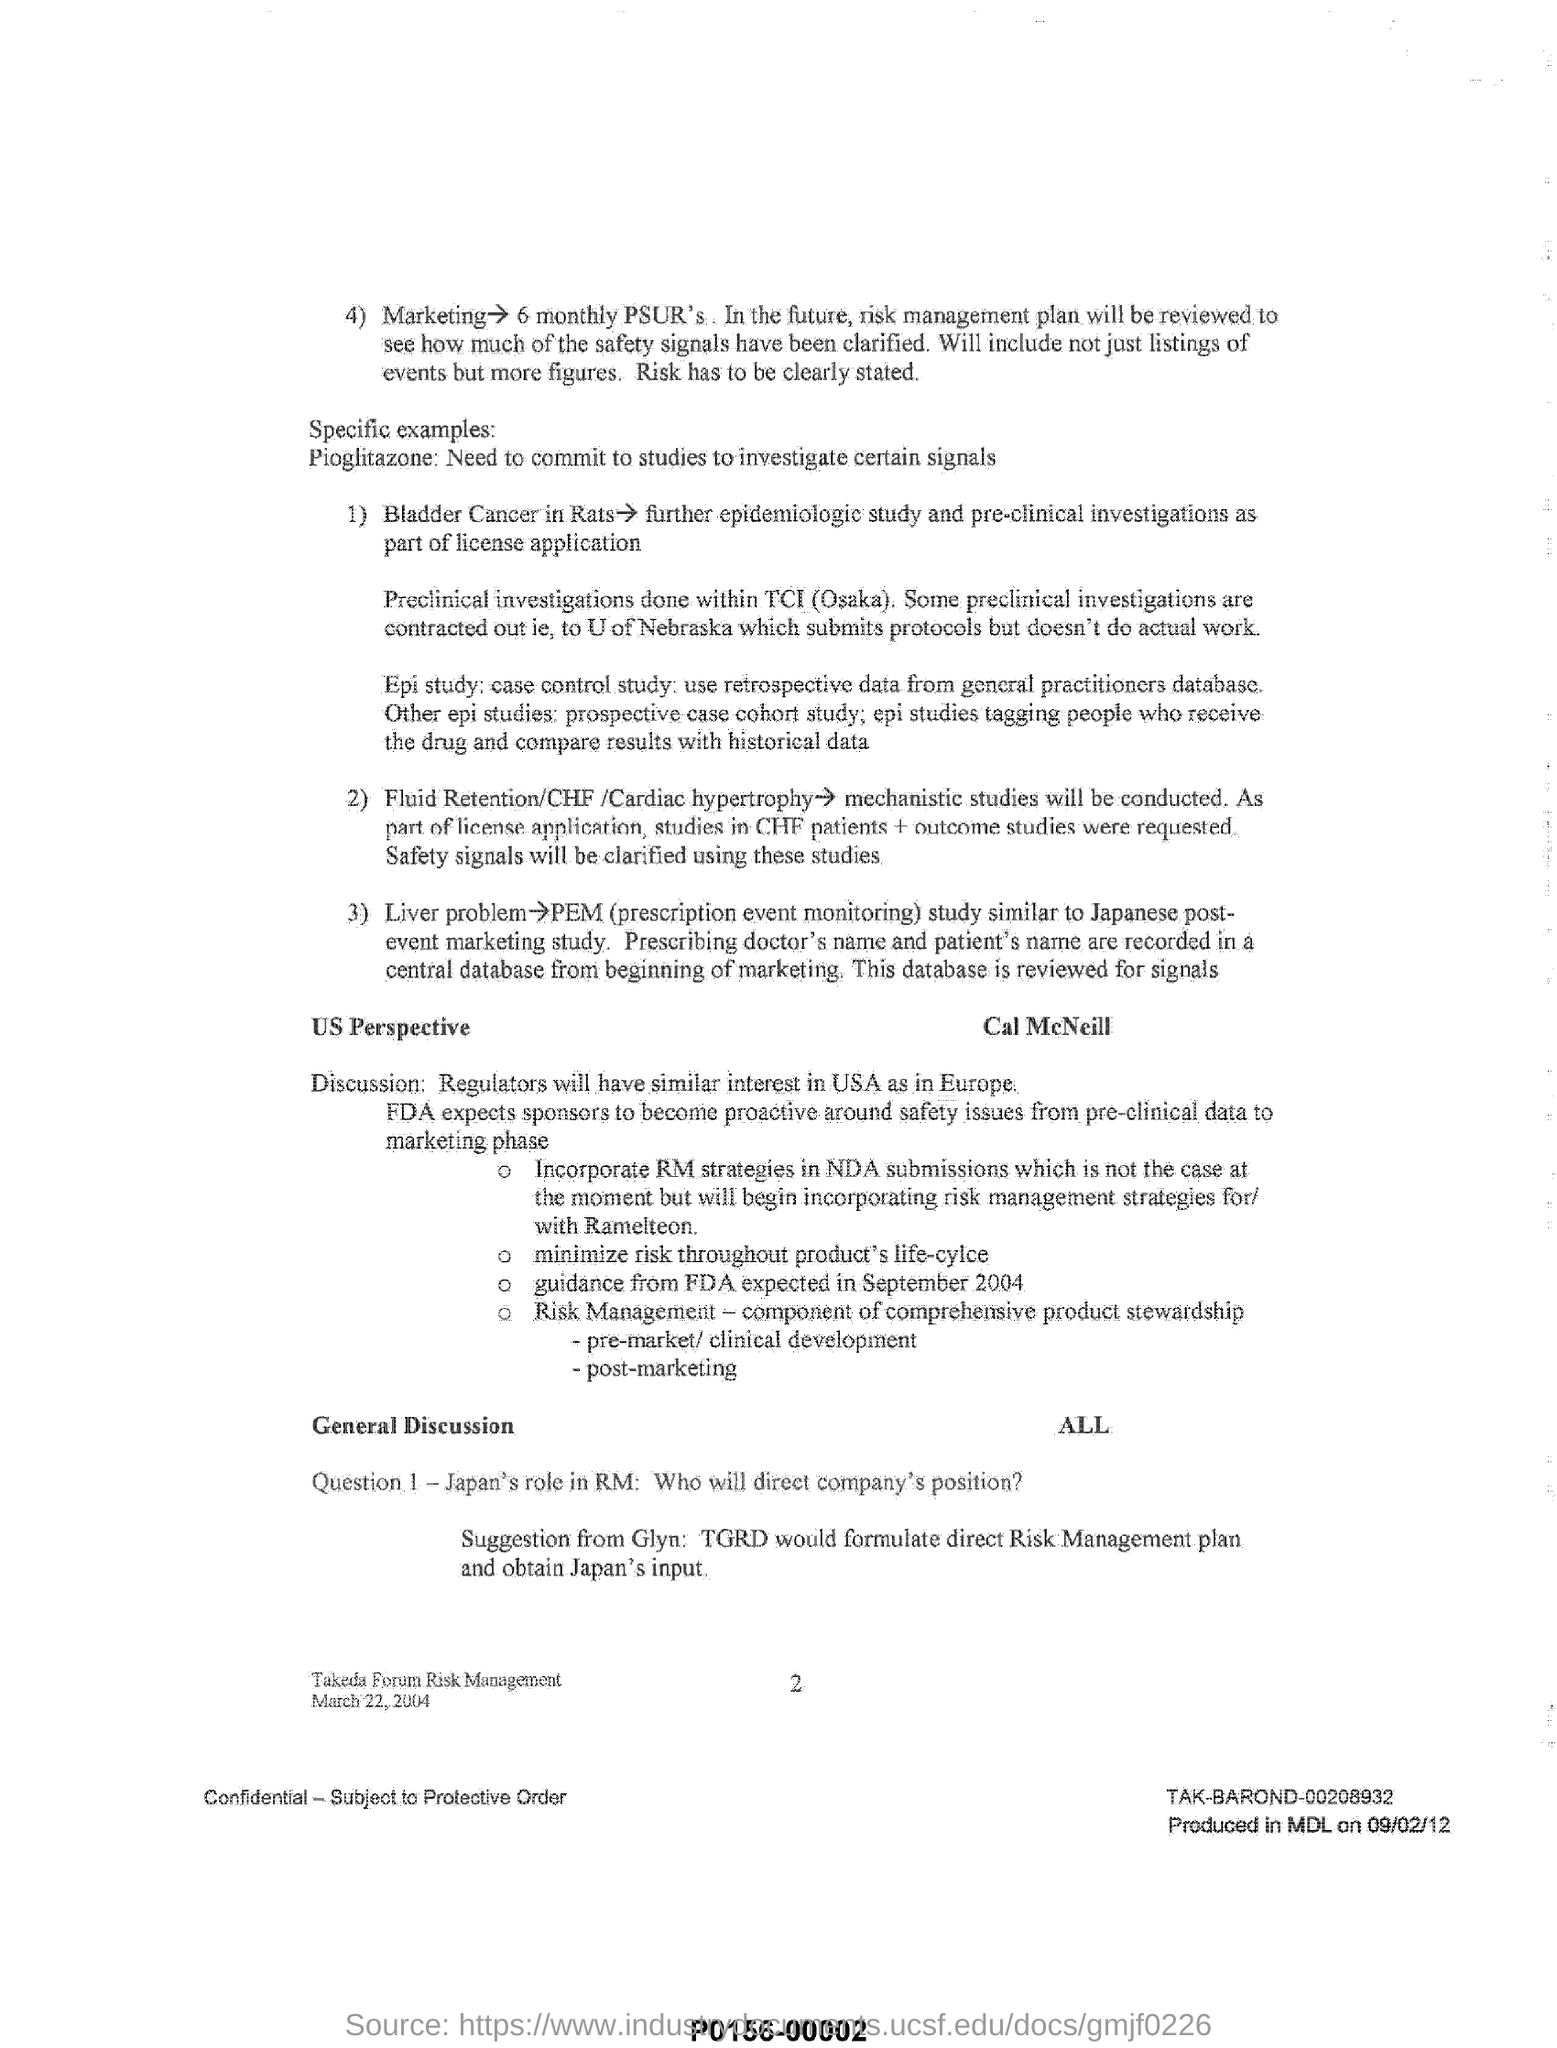What is the Specific example given?
Your response must be concise. Pioglitazone: Need to commit to studies to investigate certain signals. Which country would have similar interest as in Europe?
Your answer should be compact. USA. What is the Suggestion from Glyn?
Provide a short and direct response. Tgrd would formulate direct risk management plan and obtain japan's input. Full form of PEM?
Ensure brevity in your answer.  Prescription event monitoring. 